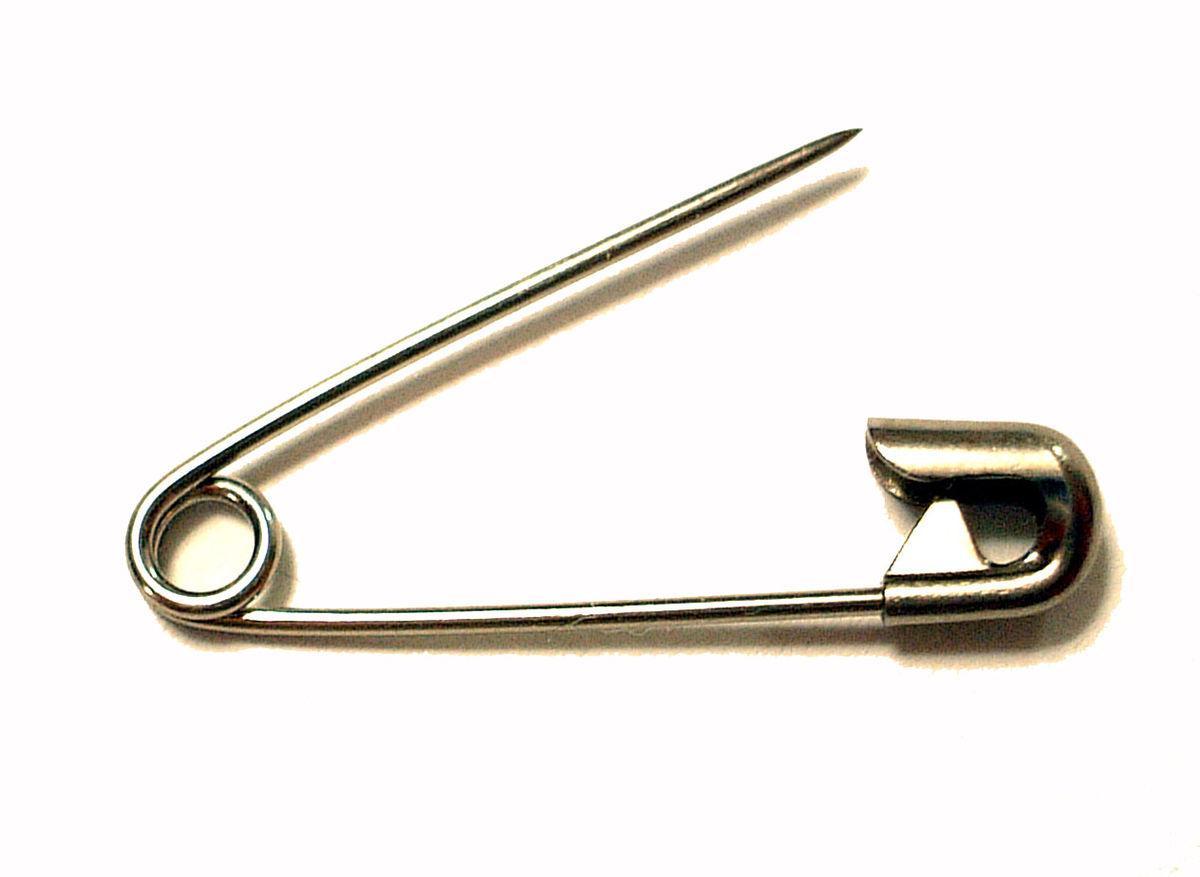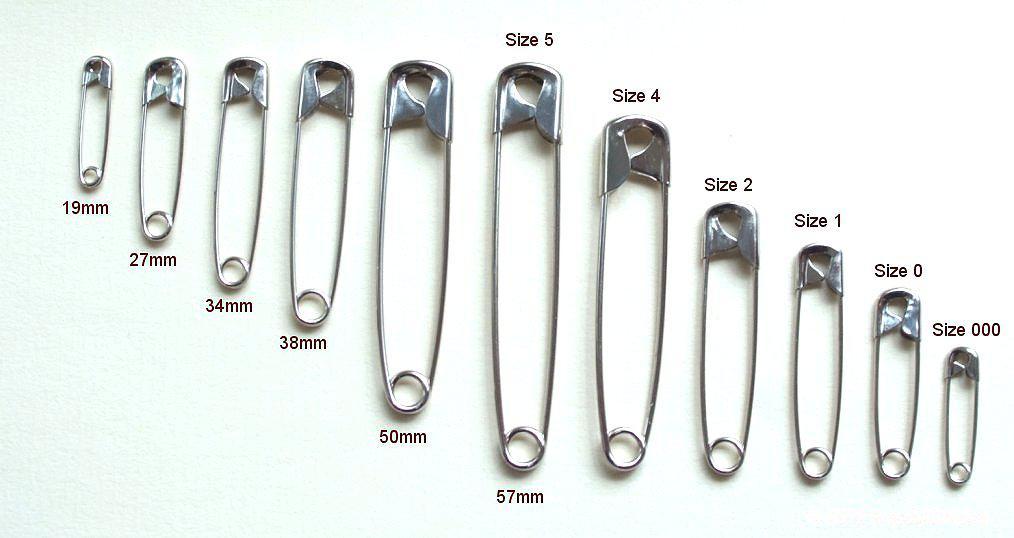The first image is the image on the left, the second image is the image on the right. Given the left and right images, does the statement "In one image, safety pins are arranged from small to large and back to small sizes." hold true? Answer yes or no. Yes. 